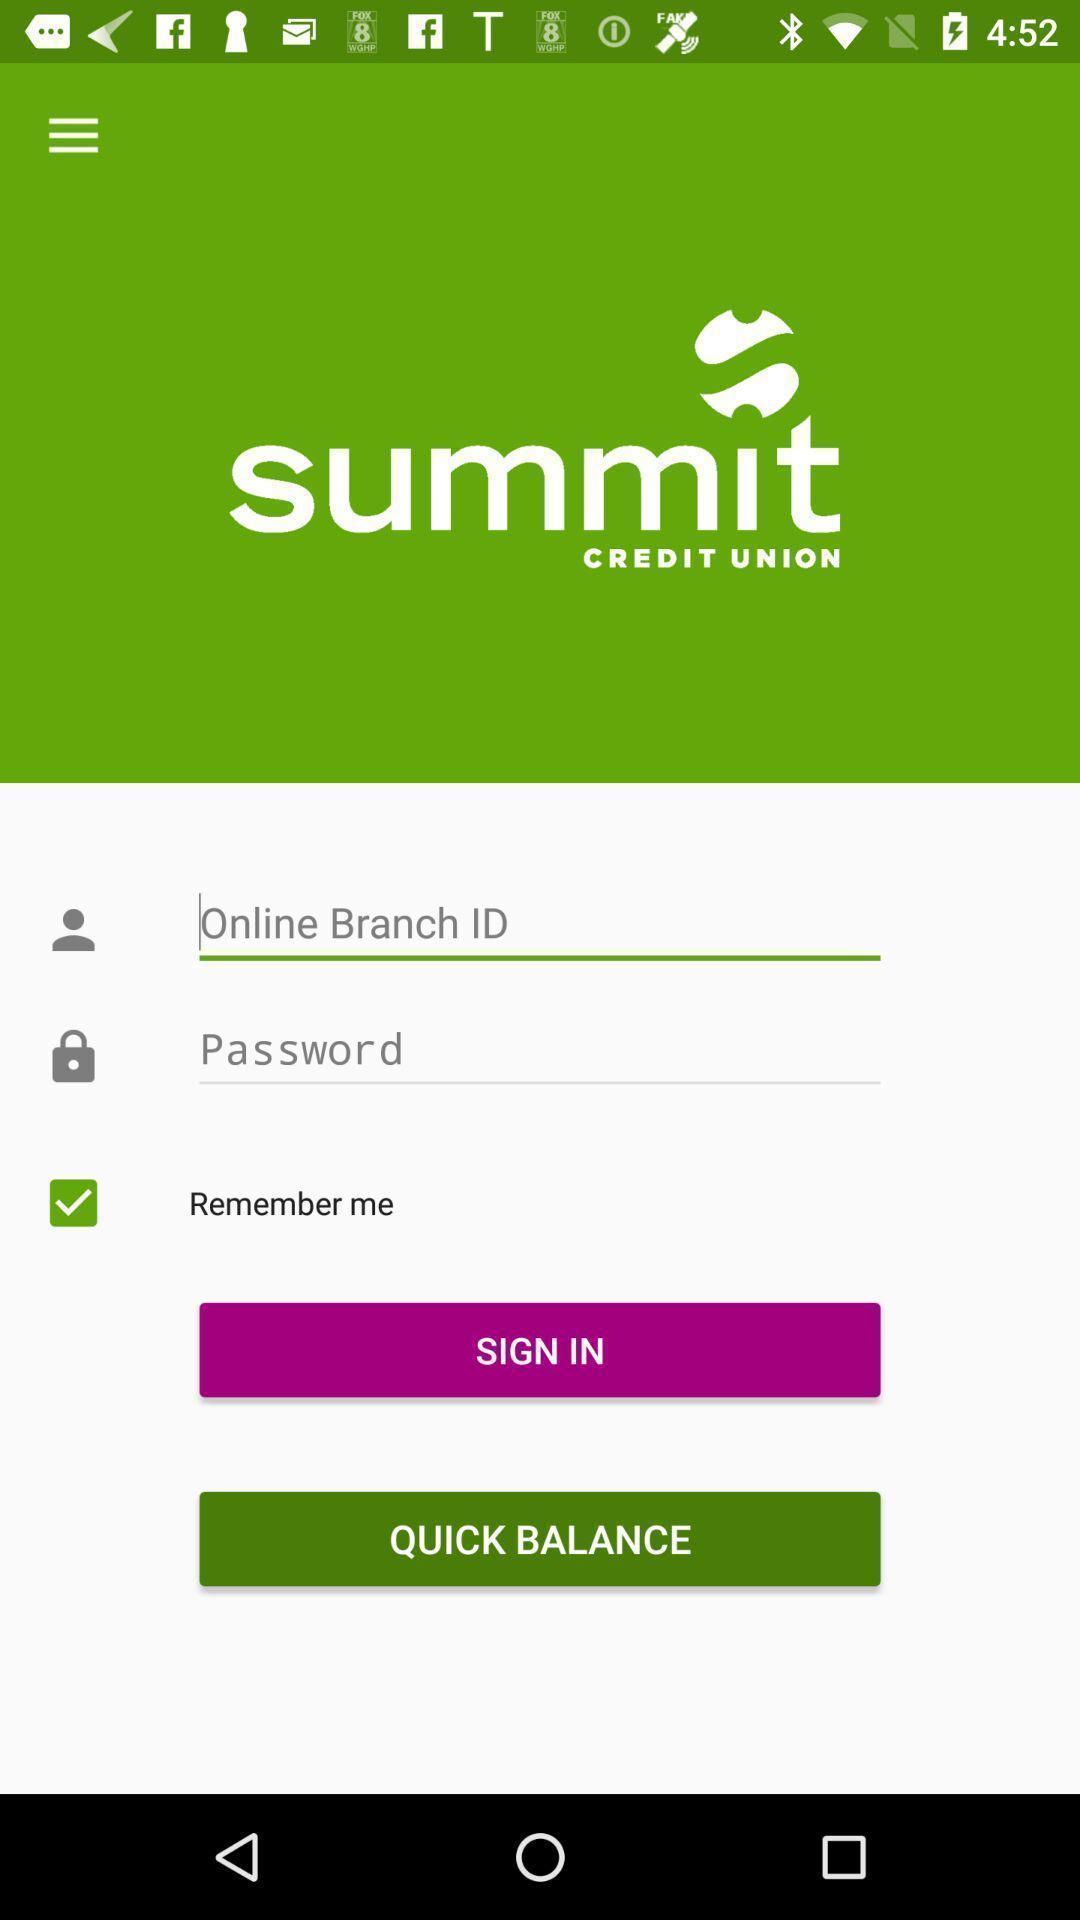Summarize the main components in this picture. Sign-in page of a mobile banking app. 